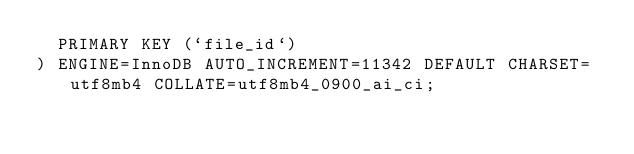Convert code to text. <code><loc_0><loc_0><loc_500><loc_500><_SQL_>  PRIMARY KEY (`file_id`)
) ENGINE=InnoDB AUTO_INCREMENT=11342 DEFAULT CHARSET=utf8mb4 COLLATE=utf8mb4_0900_ai_ci;
</code> 